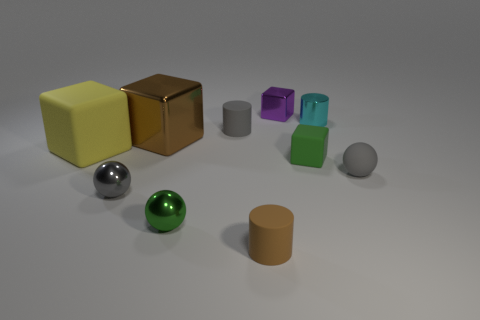Subtract all gray blocks. Subtract all green balls. How many blocks are left? 4 Subtract all spheres. How many objects are left? 7 Add 5 purple metallic cubes. How many purple metallic cubes exist? 6 Subtract 0 cyan spheres. How many objects are left? 10 Subtract all big shiny cubes. Subtract all tiny purple metal things. How many objects are left? 8 Add 2 metal objects. How many metal objects are left? 7 